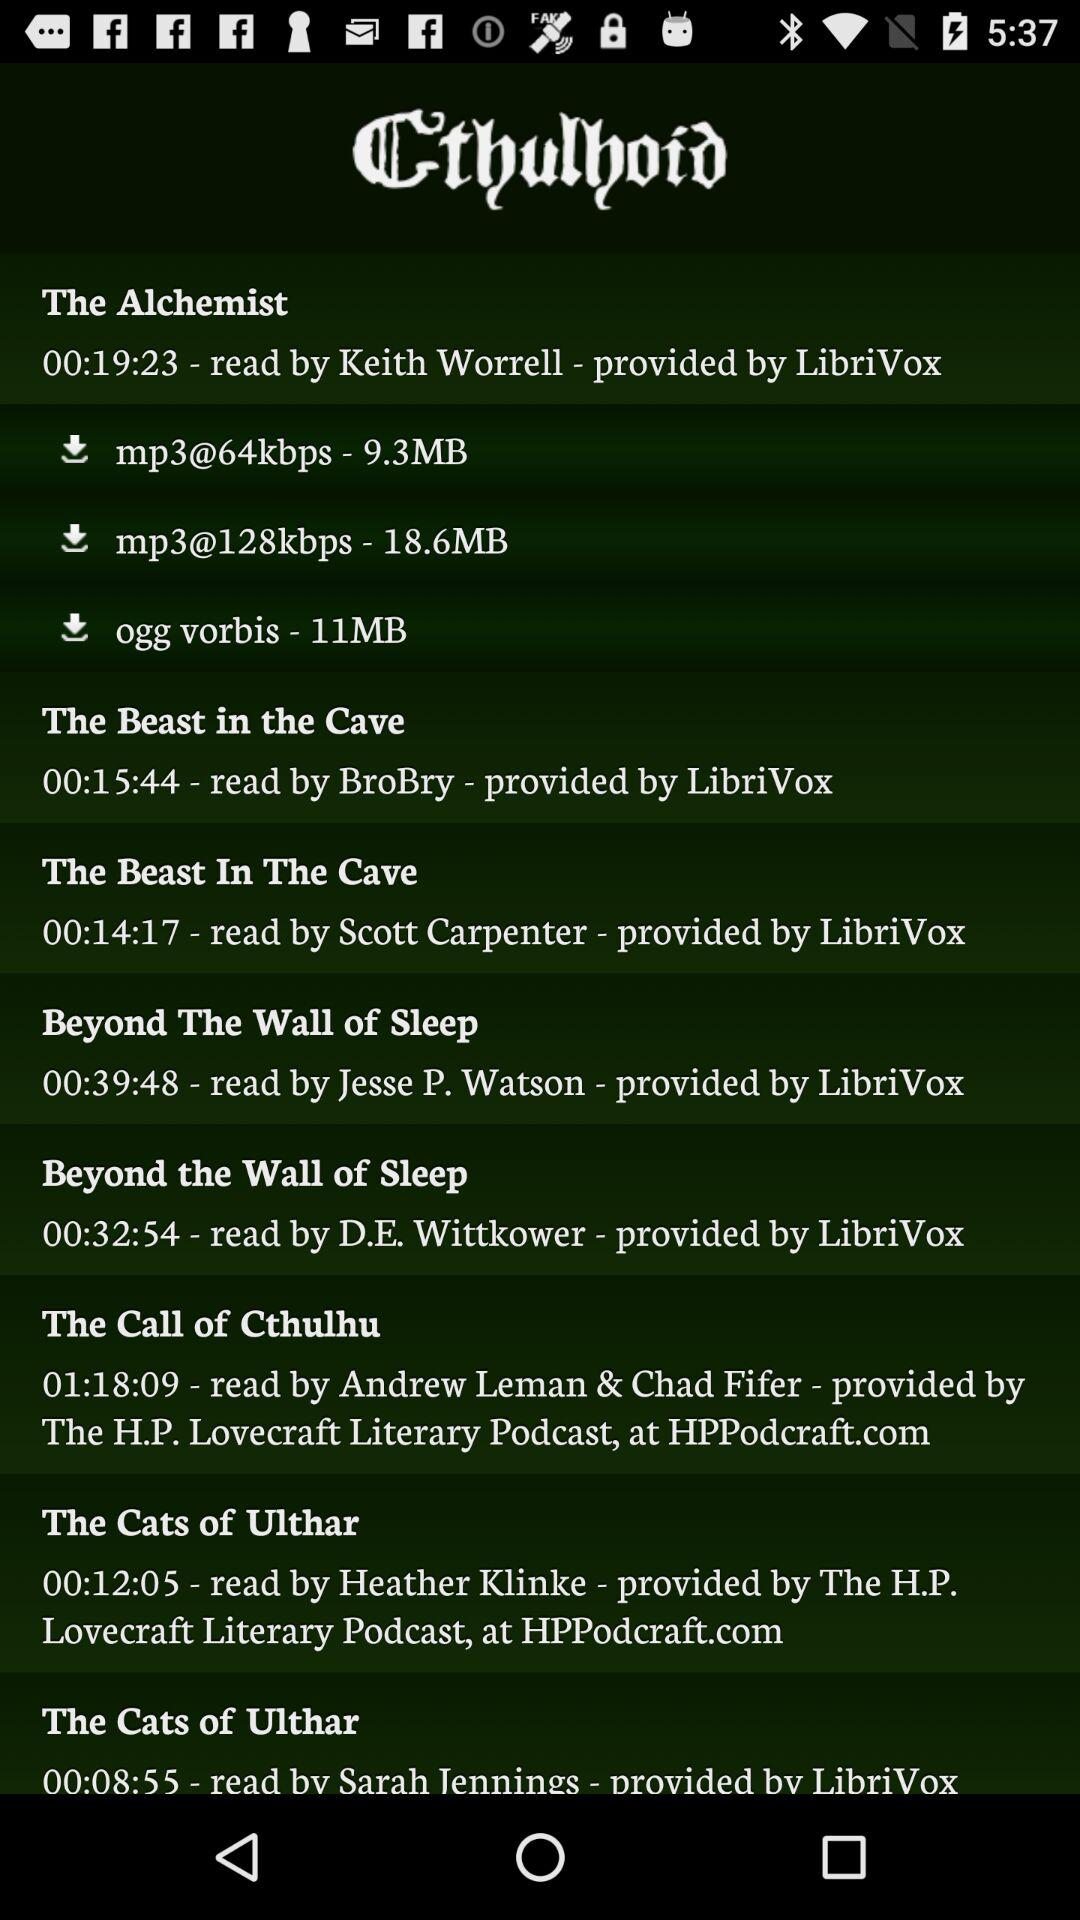Who's the reader of "The Call of Cthulhu" audiobook? The readers of "The Call of Cthulhu" audiobook are Andrew Leman and Chad Fifer. 